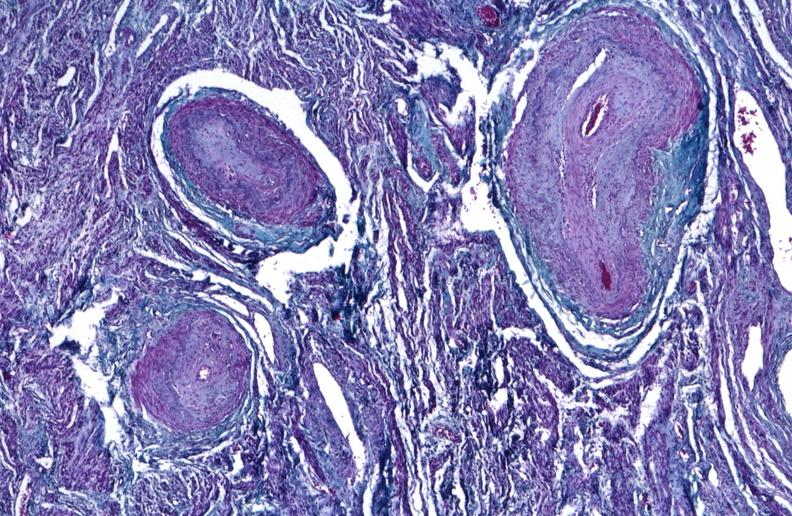what does this image show?
Answer the question using a single word or phrase. Kidney 